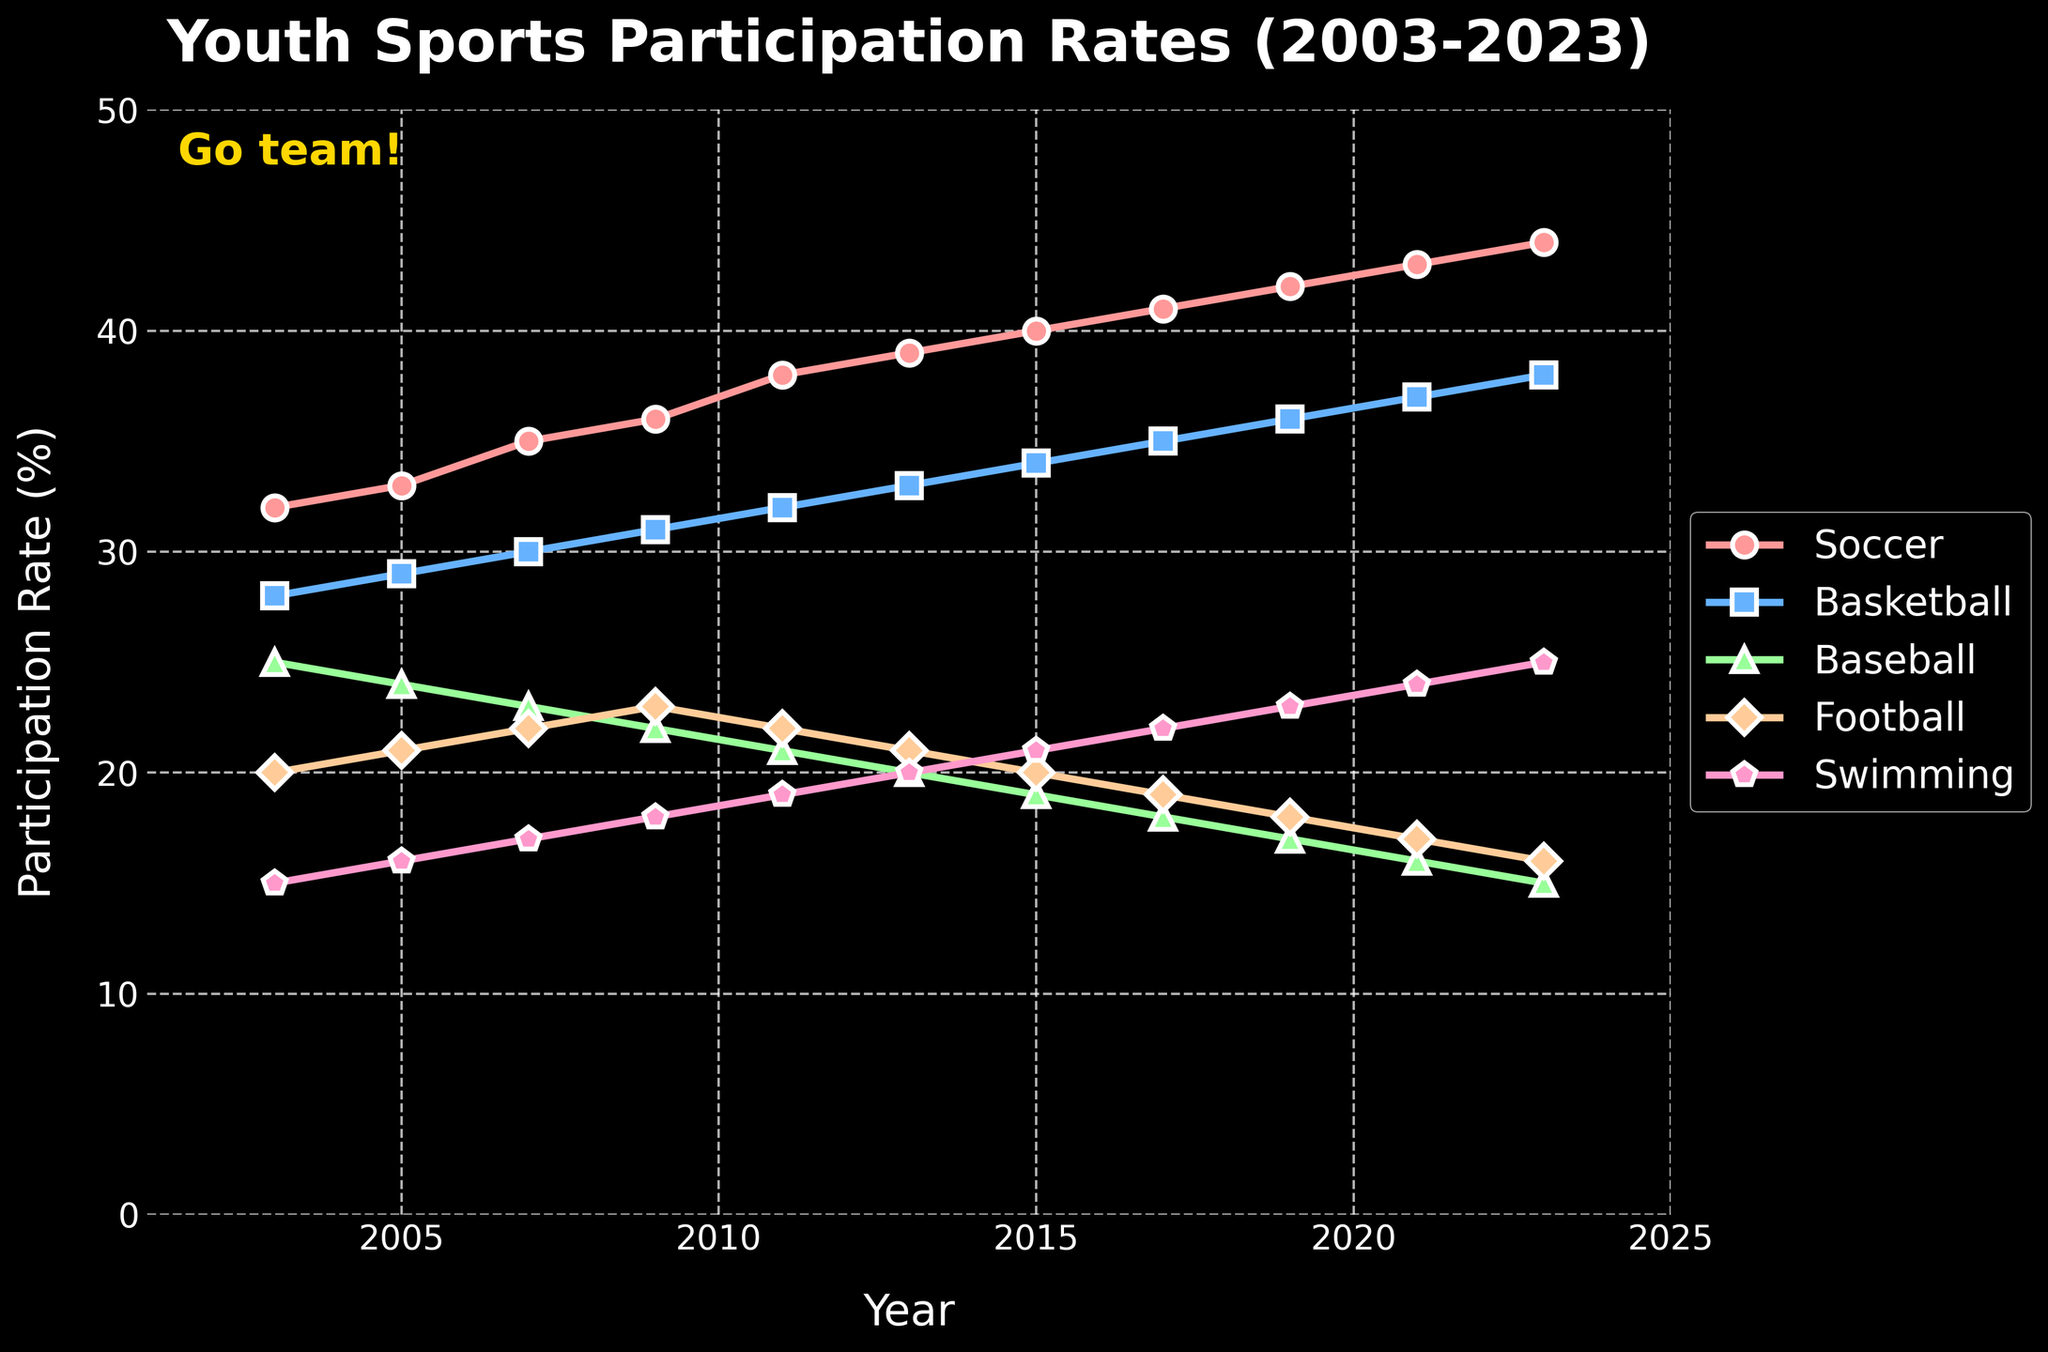Which sport had the highest participation rates in 2003? The sport with the highest participation rates in 2003 is represented by the highest point in the figure at the year 2003. According to the figure, Soccer has the highest participation rate in 2003 at 32%.
Answer: Soccer How much did Soccer participation increase from 2003 to 2023? The participation rate of Soccer in 2003 is 32%, and in 2023 it is 44%. The increase is calculated as 44% - 32% = 12%.
Answer: 12% Which sport showed the greatest increase in participation rates over the 20-year period? To determine this, we need to look at the differences between the start (2003) and end (2023) values for each sport in the figure. Soccer increased from 32% to 44% (12%), Basketball from 28% to 38% (10%), Baseball decreased from 25% to 15% (-10%), Football from 20% to 16% (-4%), and Swimming from 15% to 25% (10%). The sport with the greatest increase is Soccer.
Answer: Soccer In which year did Basketball surpass Baseball in participation rates? Tracking the lines for Basketball and Baseball, Basketball surpasses Baseball when the Basketball line crosses above the Baseball line. This happens between 2007 and 2009 as Basketball was already above Baseball by 2009.
Answer: 2009 How do the participation trends of Football and Baseball compare over the last 10 years? Over the last 10 years, from 2013 to 2023, Football participation declined from 21% to 16%, and Baseball participation also declined from 20% to 15%. Both sports show a decrease in participation rates, though Football’s decline is 5% and Baseball’s decline is also 5%.
Answer: Both declined, same amount What are the participation rates of Swimming in 2011 and 2023, and what is the difference? According to the figure, Swimming had a participation rate of 19% in 2011 and 25% in 2023. The difference is 25% - 19% = 6%.
Answer: 6% Which sport had the lowest participation rate in 2023 and what was its value? The sport with the lowest participation rate in 2023 is represented by the lowest point in the figure at the year 2023. According to the figure, Baseball had the lowest participation rate at 15%.
Answer: Baseball, 15% What was the average participation rate for Swimming between 2003 and 2023? To find the average, add the participation rates for Swimming over all the years and divide by the number of years: (15 + 16 + 17 + 18 + 19 + 20 + 21 + 22 + 23 + 24 + 25) / 11 = 220 / 11 = 20%.
Answer: 20% Which sports had increasing trends over the entire period from 2003 to 2023? By observing the figure, the sports with lines that continuously rise from 2003 to 2023 indicate increasing trends. Soccer, Basketball, and Swimming all show increasing trends without any dips.
Answer: Soccer, Basketball, Swimming 